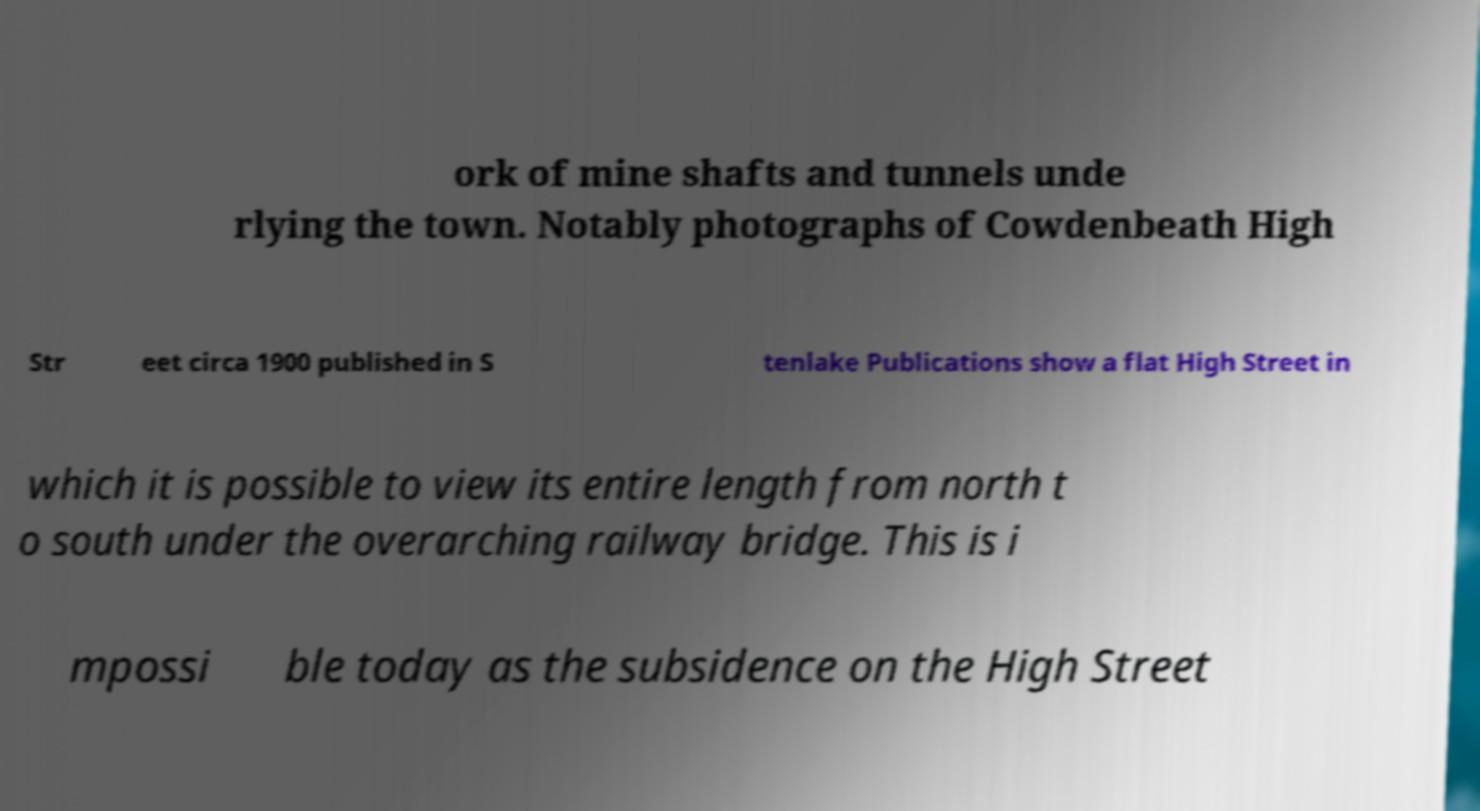What messages or text are displayed in this image? I need them in a readable, typed format. ork of mine shafts and tunnels unde rlying the town. Notably photographs of Cowdenbeath High Str eet circa 1900 published in S tenlake Publications show a flat High Street in which it is possible to view its entire length from north t o south under the overarching railway bridge. This is i mpossi ble today as the subsidence on the High Street 